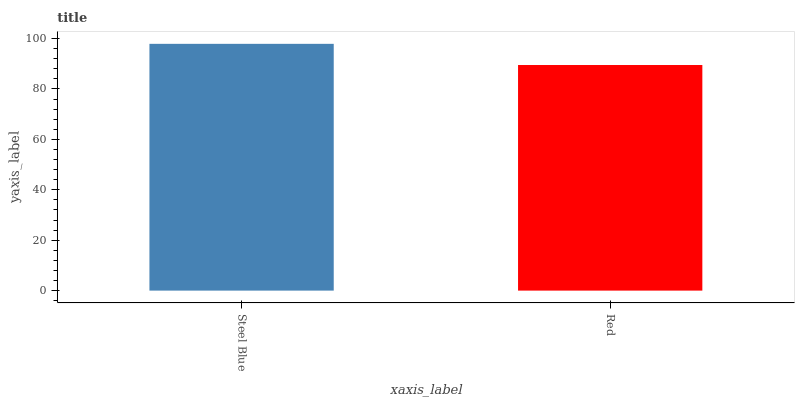Is Red the minimum?
Answer yes or no. Yes. Is Steel Blue the maximum?
Answer yes or no. Yes. Is Red the maximum?
Answer yes or no. No. Is Steel Blue greater than Red?
Answer yes or no. Yes. Is Red less than Steel Blue?
Answer yes or no. Yes. Is Red greater than Steel Blue?
Answer yes or no. No. Is Steel Blue less than Red?
Answer yes or no. No. Is Steel Blue the high median?
Answer yes or no. Yes. Is Red the low median?
Answer yes or no. Yes. Is Red the high median?
Answer yes or no. No. Is Steel Blue the low median?
Answer yes or no. No. 